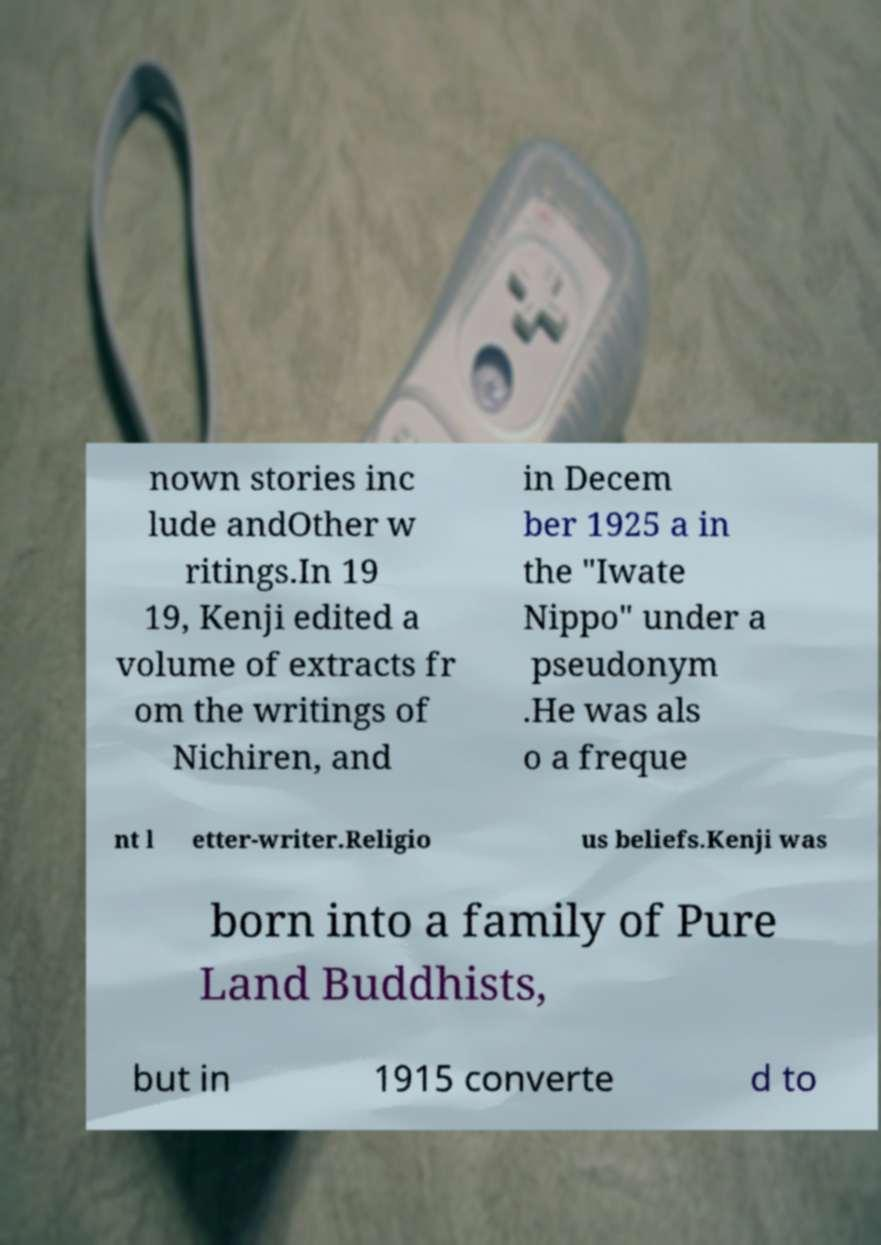Can you read and provide the text displayed in the image?This photo seems to have some interesting text. Can you extract and type it out for me? nown stories inc lude andOther w ritings.In 19 19, Kenji edited a volume of extracts fr om the writings of Nichiren, and in Decem ber 1925 a in the "Iwate Nippo" under a pseudonym .He was als o a freque nt l etter-writer.Religio us beliefs.Kenji was born into a family of Pure Land Buddhists, but in 1915 converte d to 